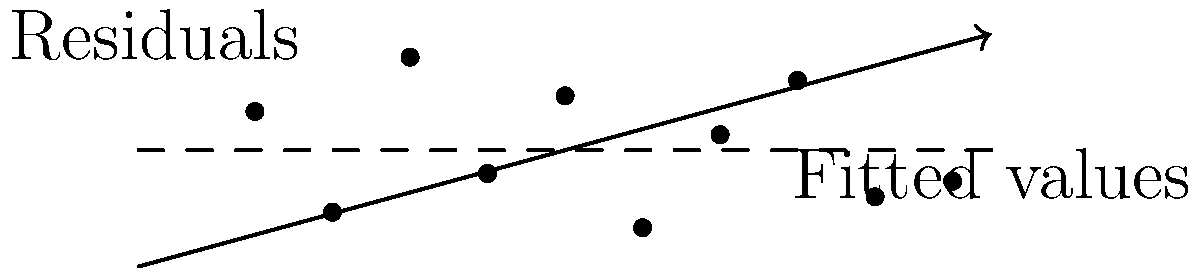Based on the residual plot shown above for a linear regression analysis, what can be concluded about the model's assumptions and fit? Provide a comprehensive interpretation of the plot, discussing any patterns or issues you observe. To interpret this residual plot, we need to examine several key aspects:

1. Distribution around zero:
   The residuals appear to be roughly evenly distributed above and below the zero line. This suggests that the assumption of zero mean for the residuals is likely met.

2. Constant variance (homoscedasticity):
   The spread of residuals seems relatively consistent across the range of fitted values. There's no clear funnel shape or other pattern indicating changing variance.

3. Linearity:
   There's no obvious curved pattern in the residuals, which suggests that the linear model is appropriate for this data.

4. Independence:
   While we can't definitively assess independence from this plot alone, there's no clear pattern (like cyclic behavior) that would indicate a violation of independence.

5. Outliers:
   There don't appear to be any extreme outliers that stand out significantly from the rest of the points.

6. Normality:
   While we can't fully assess normality from this plot, the spread of residuals appears reasonably symmetric.

7. Model fit:
   The residuals are scattered fairly randomly, which is a good sign. However, there might be a slight tendency for more negative residuals in the middle of the range of fitted values.

8. Range of residuals:
   The residuals mostly fall within the range of -1 to 1, which seems reasonable relative to the scale of the data.

Based on these observations, the linear regression model appears to be a reasonable fit for the data. The main assumptions of linear regression (linearity, homoscedasticity, and independence) seem to be met. However, a slight pattern in the middle range of fitted values might warrant further investigation.
Answer: The residual plot suggests a reasonably good fit with no major violations of linear regression assumptions, though there might be a slight pattern in the middle range of fitted values worth investigating further. 